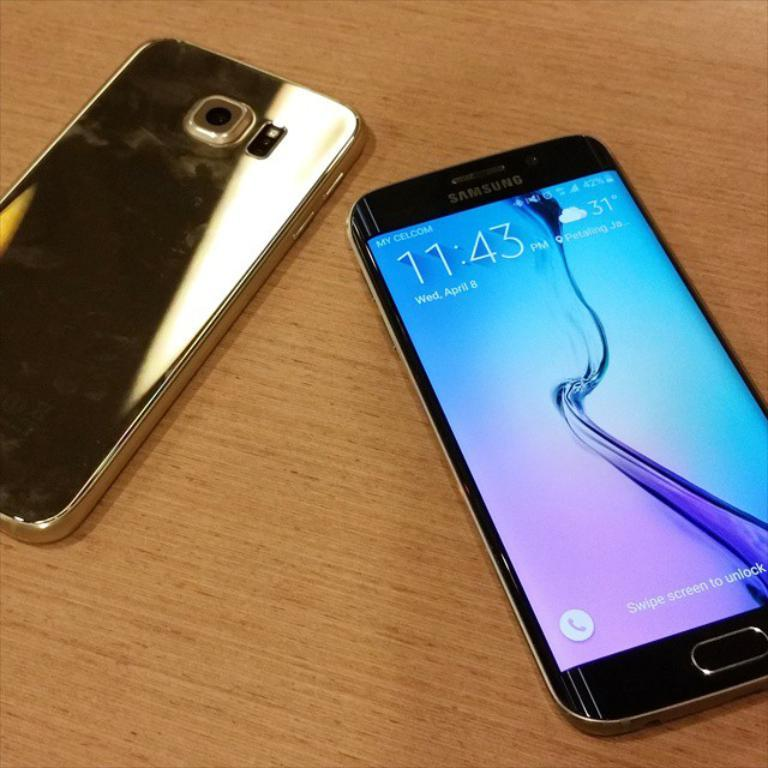<image>
Render a clear and concise summary of the photo. A Samsung phone displays the date and time on the lock screen. 